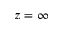Convert formula to latex. <formula><loc_0><loc_0><loc_500><loc_500>z = \infty</formula> 